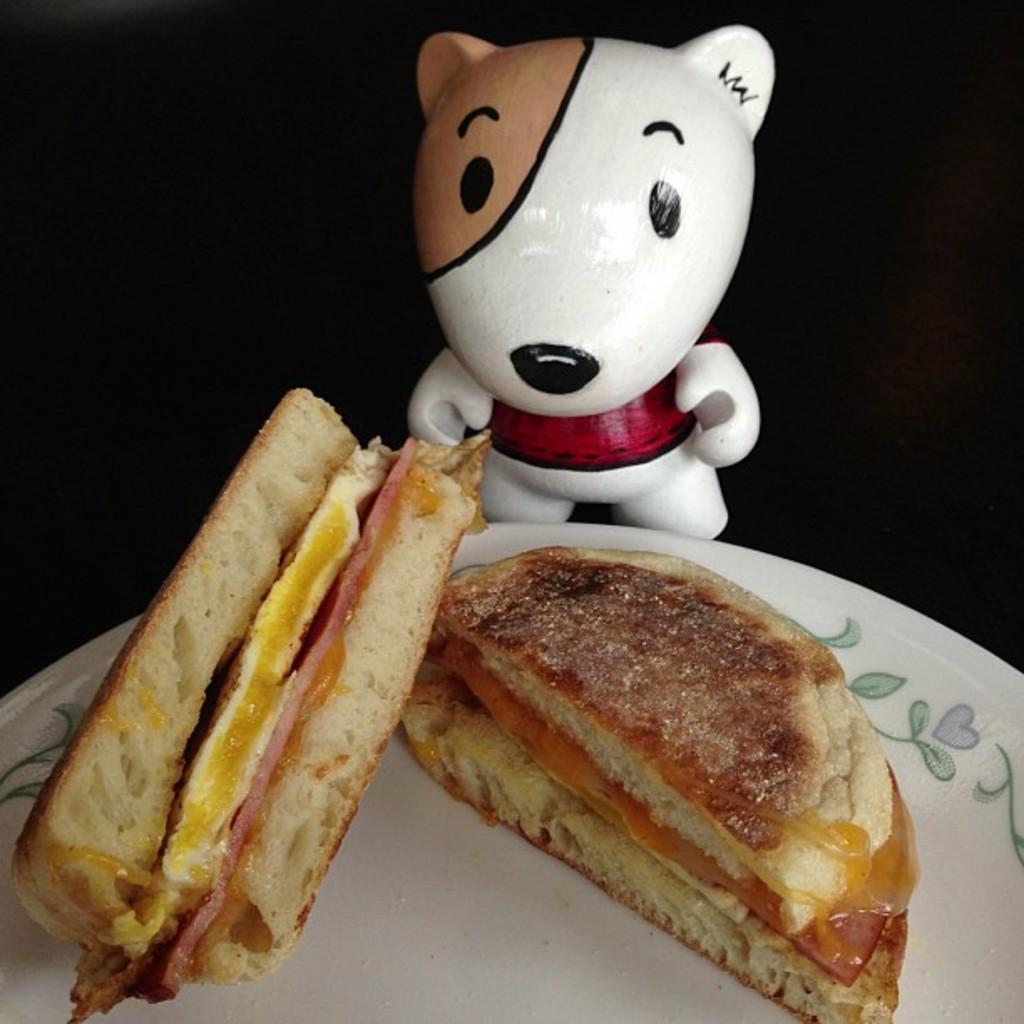Could you give a brief overview of what you see in this image? In this picture I can see there is some food on the plate and there is a doll behind the plate. The backdrop is dark. 